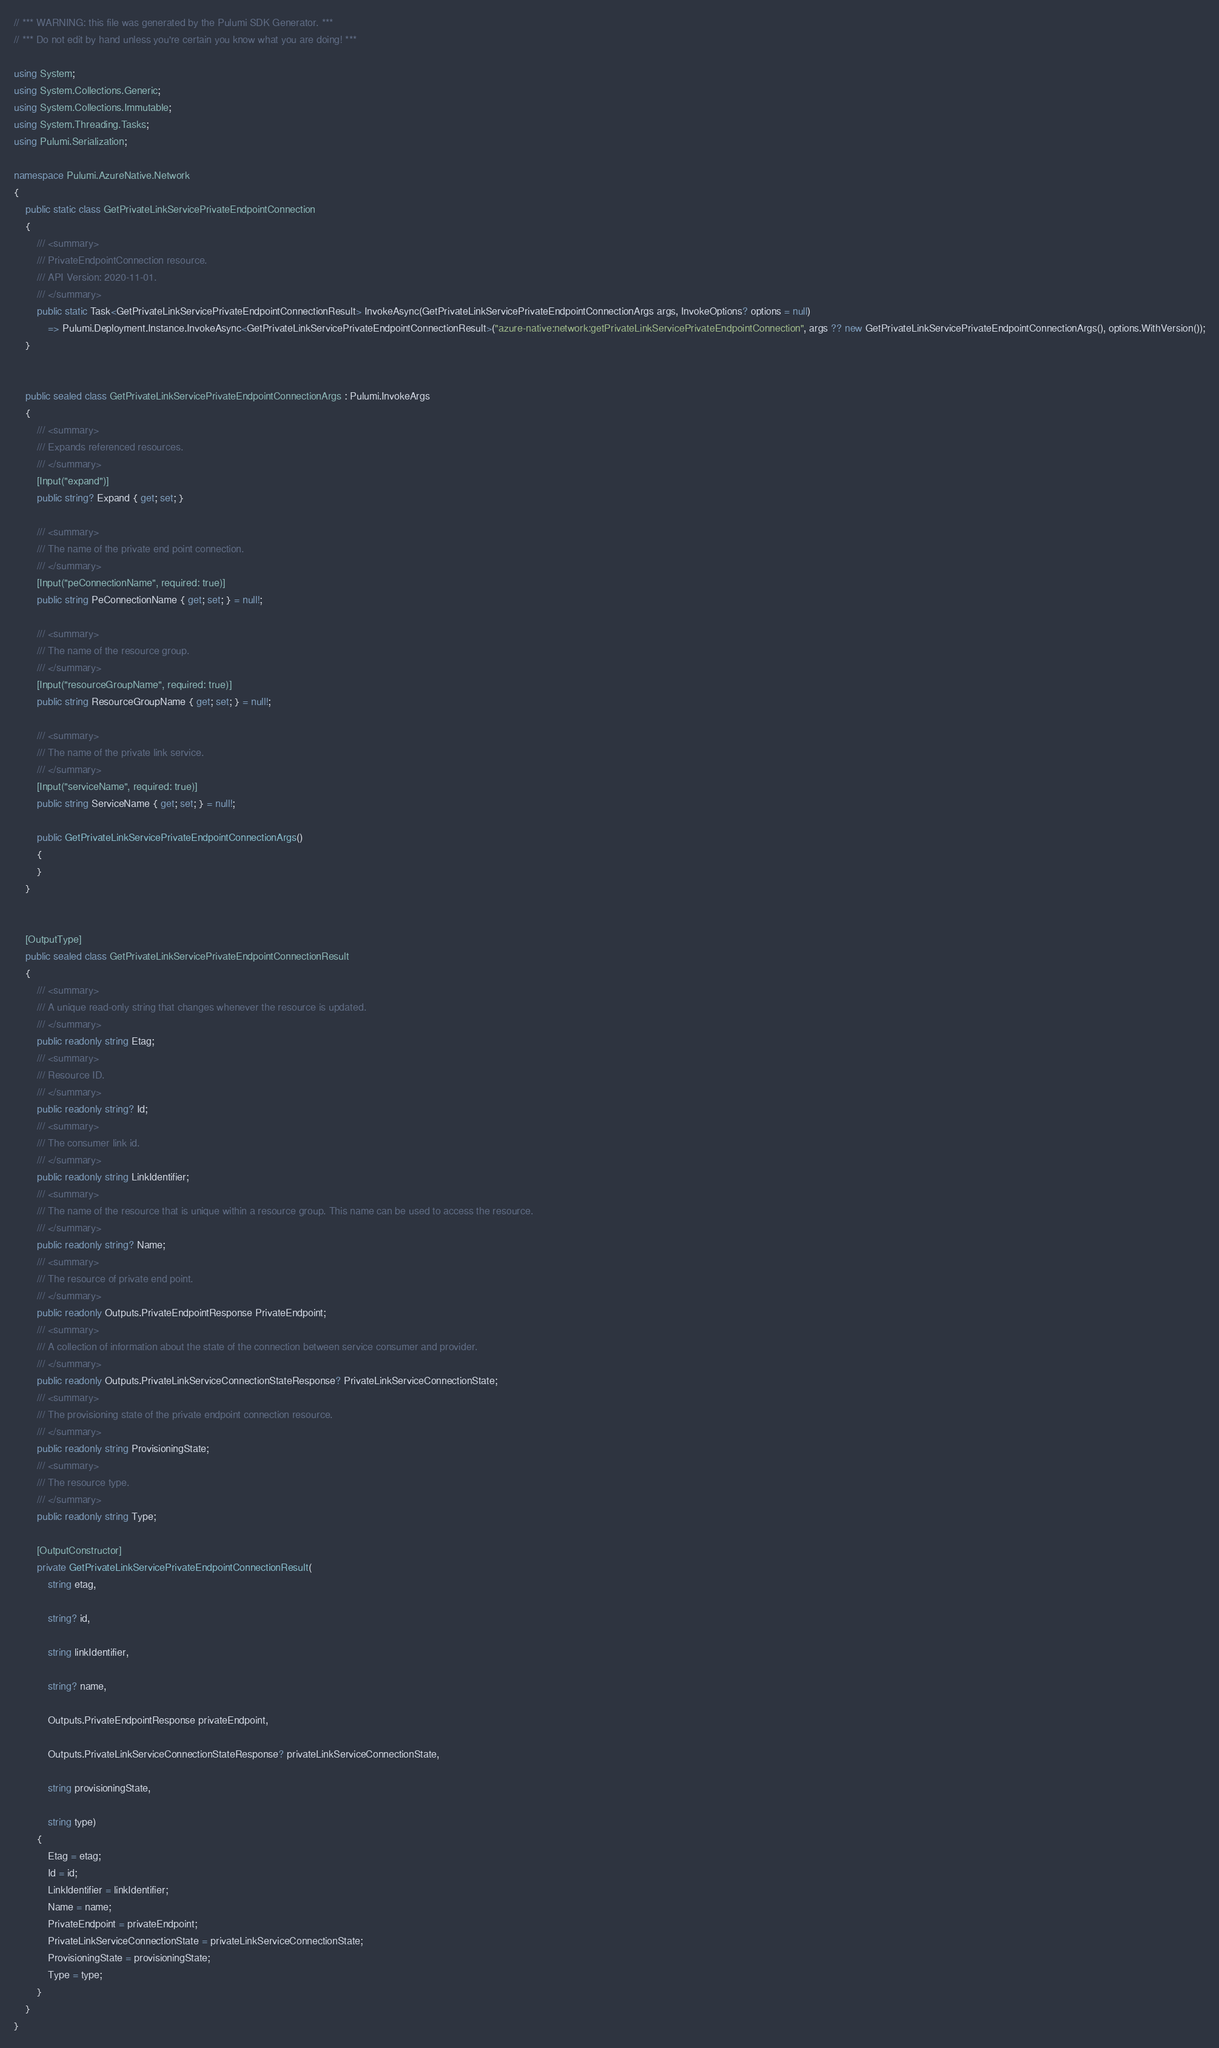<code> <loc_0><loc_0><loc_500><loc_500><_C#_>// *** WARNING: this file was generated by the Pulumi SDK Generator. ***
// *** Do not edit by hand unless you're certain you know what you are doing! ***

using System;
using System.Collections.Generic;
using System.Collections.Immutable;
using System.Threading.Tasks;
using Pulumi.Serialization;

namespace Pulumi.AzureNative.Network
{
    public static class GetPrivateLinkServicePrivateEndpointConnection
    {
        /// <summary>
        /// PrivateEndpointConnection resource.
        /// API Version: 2020-11-01.
        /// </summary>
        public static Task<GetPrivateLinkServicePrivateEndpointConnectionResult> InvokeAsync(GetPrivateLinkServicePrivateEndpointConnectionArgs args, InvokeOptions? options = null)
            => Pulumi.Deployment.Instance.InvokeAsync<GetPrivateLinkServicePrivateEndpointConnectionResult>("azure-native:network:getPrivateLinkServicePrivateEndpointConnection", args ?? new GetPrivateLinkServicePrivateEndpointConnectionArgs(), options.WithVersion());
    }


    public sealed class GetPrivateLinkServicePrivateEndpointConnectionArgs : Pulumi.InvokeArgs
    {
        /// <summary>
        /// Expands referenced resources.
        /// </summary>
        [Input("expand")]
        public string? Expand { get; set; }

        /// <summary>
        /// The name of the private end point connection.
        /// </summary>
        [Input("peConnectionName", required: true)]
        public string PeConnectionName { get; set; } = null!;

        /// <summary>
        /// The name of the resource group.
        /// </summary>
        [Input("resourceGroupName", required: true)]
        public string ResourceGroupName { get; set; } = null!;

        /// <summary>
        /// The name of the private link service.
        /// </summary>
        [Input("serviceName", required: true)]
        public string ServiceName { get; set; } = null!;

        public GetPrivateLinkServicePrivateEndpointConnectionArgs()
        {
        }
    }


    [OutputType]
    public sealed class GetPrivateLinkServicePrivateEndpointConnectionResult
    {
        /// <summary>
        /// A unique read-only string that changes whenever the resource is updated.
        /// </summary>
        public readonly string Etag;
        /// <summary>
        /// Resource ID.
        /// </summary>
        public readonly string? Id;
        /// <summary>
        /// The consumer link id.
        /// </summary>
        public readonly string LinkIdentifier;
        /// <summary>
        /// The name of the resource that is unique within a resource group. This name can be used to access the resource.
        /// </summary>
        public readonly string? Name;
        /// <summary>
        /// The resource of private end point.
        /// </summary>
        public readonly Outputs.PrivateEndpointResponse PrivateEndpoint;
        /// <summary>
        /// A collection of information about the state of the connection between service consumer and provider.
        /// </summary>
        public readonly Outputs.PrivateLinkServiceConnectionStateResponse? PrivateLinkServiceConnectionState;
        /// <summary>
        /// The provisioning state of the private endpoint connection resource.
        /// </summary>
        public readonly string ProvisioningState;
        /// <summary>
        /// The resource type.
        /// </summary>
        public readonly string Type;

        [OutputConstructor]
        private GetPrivateLinkServicePrivateEndpointConnectionResult(
            string etag,

            string? id,

            string linkIdentifier,

            string? name,

            Outputs.PrivateEndpointResponse privateEndpoint,

            Outputs.PrivateLinkServiceConnectionStateResponse? privateLinkServiceConnectionState,

            string provisioningState,

            string type)
        {
            Etag = etag;
            Id = id;
            LinkIdentifier = linkIdentifier;
            Name = name;
            PrivateEndpoint = privateEndpoint;
            PrivateLinkServiceConnectionState = privateLinkServiceConnectionState;
            ProvisioningState = provisioningState;
            Type = type;
        }
    }
}
</code> 